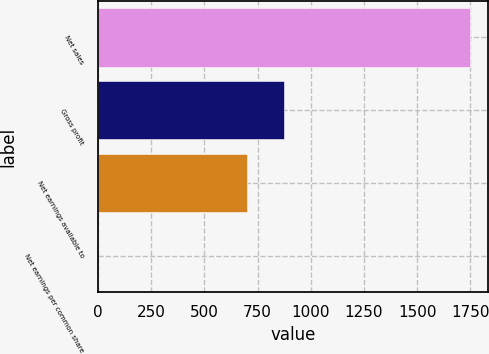<chart> <loc_0><loc_0><loc_500><loc_500><bar_chart><fcel>Net sales<fcel>Gross profit<fcel>Net earnings available to<fcel>Net earnings per common share<nl><fcel>1746.2<fcel>873.23<fcel>698.64<fcel>0.28<nl></chart> 